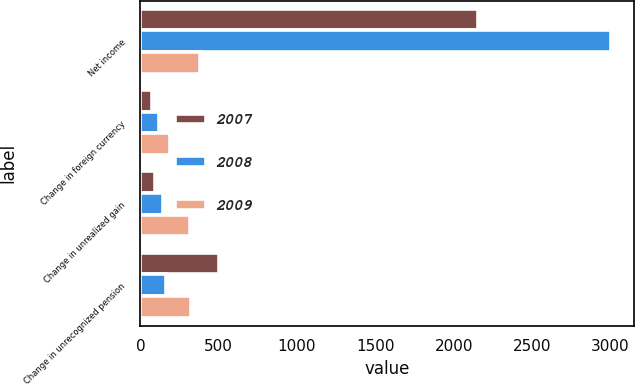Convert chart to OTSL. <chart><loc_0><loc_0><loc_500><loc_500><stacked_bar_chart><ecel><fcel>Net income<fcel>Change in foreign currency<fcel>Change in unrealized gain<fcel>Change in unrecognized pension<nl><fcel>2007<fcel>2152<fcel>75<fcel>93<fcel>500<nl><fcel>2008<fcel>3003<fcel>119<fcel>143<fcel>166.5<nl><fcel>2009<fcel>382<fcel>190<fcel>318<fcel>323<nl></chart> 